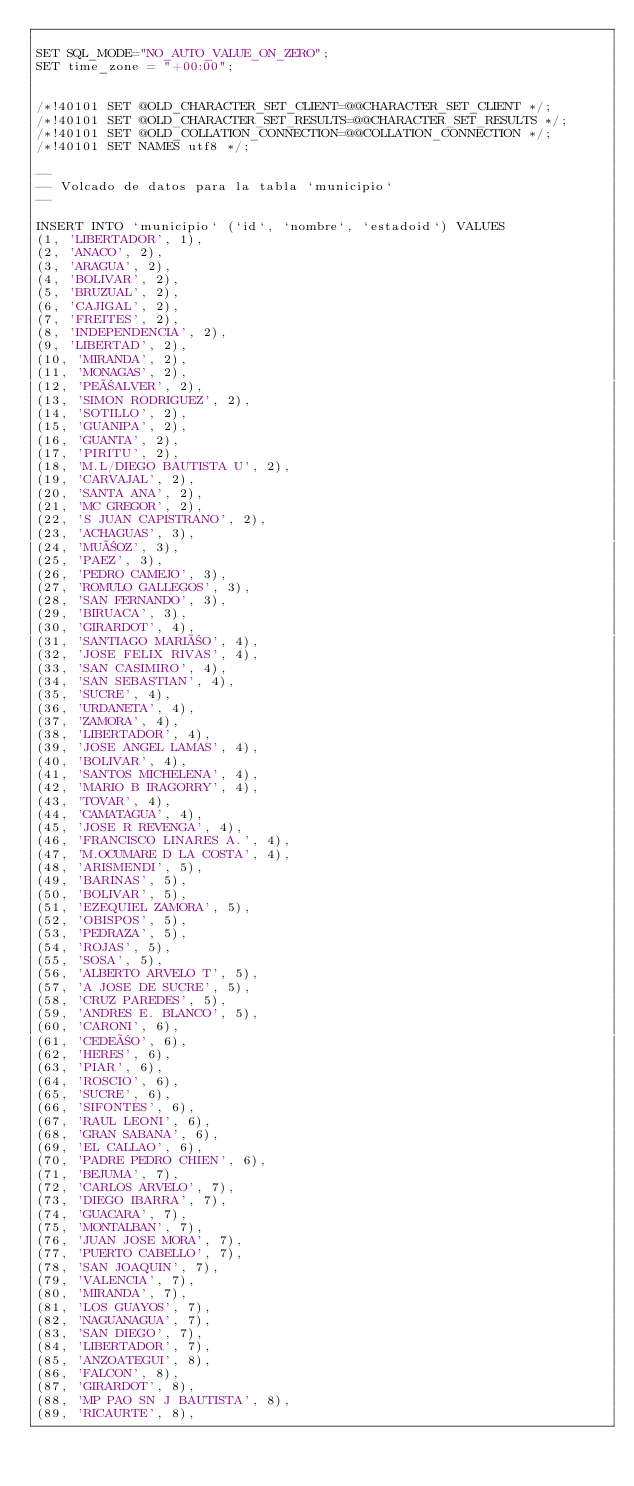Convert code to text. <code><loc_0><loc_0><loc_500><loc_500><_SQL_>
SET SQL_MODE="NO_AUTO_VALUE_ON_ZERO";
SET time_zone = "+00:00";


/*!40101 SET @OLD_CHARACTER_SET_CLIENT=@@CHARACTER_SET_CLIENT */;
/*!40101 SET @OLD_CHARACTER_SET_RESULTS=@@CHARACTER_SET_RESULTS */;
/*!40101 SET @OLD_COLLATION_CONNECTION=@@COLLATION_CONNECTION */;
/*!40101 SET NAMES utf8 */;

--
-- Volcado de datos para la tabla `municipio`
--

INSERT INTO `municipio` (`id`, `nombre`, `estadoid`) VALUES
(1, 'LIBERTADOR', 1),
(2, 'ANACO', 2),
(3, 'ARAGUA', 2),
(4, 'BOLIVAR', 2),
(5, 'BRUZUAL', 2),
(6, 'CAJIGAL', 2),
(7, 'FREITES', 2),
(8, 'INDEPENDENCIA', 2),
(9, 'LIBERTAD', 2),
(10, 'MIRANDA', 2),
(11, 'MONAGAS', 2),
(12, 'PEÑALVER', 2),
(13, 'SIMON RODRIGUEZ', 2),
(14, 'SOTILLO', 2),
(15, 'GUANIPA', 2),
(16, 'GUANTA', 2),
(17, 'PIRITU', 2),
(18, 'M.L/DIEGO BAUTISTA U', 2),
(19, 'CARVAJAL', 2),
(20, 'SANTA ANA', 2),
(21, 'MC GREGOR', 2),
(22, 'S JUAN CAPISTRANO', 2),
(23, 'ACHAGUAS', 3),
(24, 'MUÑOZ', 3),
(25, 'PAEZ', 3),
(26, 'PEDRO CAMEJO', 3),
(27, 'ROMULO GALLEGOS', 3),
(28, 'SAN FERNANDO', 3),
(29, 'BIRUACA', 3),
(30, 'GIRARDOT', 4),
(31, 'SANTIAGO MARIÑO', 4),
(32, 'JOSE FELIX RIVAS', 4),
(33, 'SAN CASIMIRO', 4),
(34, 'SAN SEBASTIAN', 4),
(35, 'SUCRE', 4),
(36, 'URDANETA', 4),
(37, 'ZAMORA', 4),
(38, 'LIBERTADOR', 4),
(39, 'JOSE ANGEL LAMAS', 4),
(40, 'BOLIVAR', 4),
(41, 'SANTOS MICHELENA', 4),
(42, 'MARIO B IRAGORRY', 4),
(43, 'TOVAR', 4),
(44, 'CAMATAGUA', 4),
(45, 'JOSE R REVENGA', 4),
(46, 'FRANCISCO LINARES A.', 4),
(47, 'M.OCUMARE D LA COSTA', 4),
(48, 'ARISMENDI', 5),
(49, 'BARINAS', 5),
(50, 'BOLIVAR', 5),
(51, 'EZEQUIEL ZAMORA', 5),
(52, 'OBISPOS', 5),
(53, 'PEDRAZA', 5),
(54, 'ROJAS', 5),
(55, 'SOSA', 5),
(56, 'ALBERTO ARVELO T', 5),
(57, 'A JOSE DE SUCRE', 5),
(58, 'CRUZ PAREDES', 5),
(59, 'ANDRES E. BLANCO', 5),
(60, 'CARONI', 6),
(61, 'CEDEÑO', 6),
(62, 'HERES', 6),
(63, 'PIAR', 6),
(64, 'ROSCIO', 6),
(65, 'SUCRE', 6),
(66, 'SIFONTES', 6),
(67, 'RAUL LEONI', 6),
(68, 'GRAN SABANA', 6),
(69, 'EL CALLAO', 6),
(70, 'PADRE PEDRO CHIEN', 6),
(71, 'BEJUMA', 7),
(72, 'CARLOS ARVELO', 7),
(73, 'DIEGO IBARRA', 7),
(74, 'GUACARA', 7),
(75, 'MONTALBAN', 7),
(76, 'JUAN JOSE MORA', 7),
(77, 'PUERTO CABELLO', 7),
(78, 'SAN JOAQUIN', 7),
(79, 'VALENCIA', 7),
(80, 'MIRANDA', 7),
(81, 'LOS GUAYOS', 7),
(82, 'NAGUANAGUA', 7),
(83, 'SAN DIEGO', 7),
(84, 'LIBERTADOR', 7),
(85, 'ANZOATEGUI', 8),
(86, 'FALCON', 8),
(87, 'GIRARDOT', 8),
(88, 'MP PAO SN J BAUTISTA', 8),
(89, 'RICAURTE', 8),</code> 